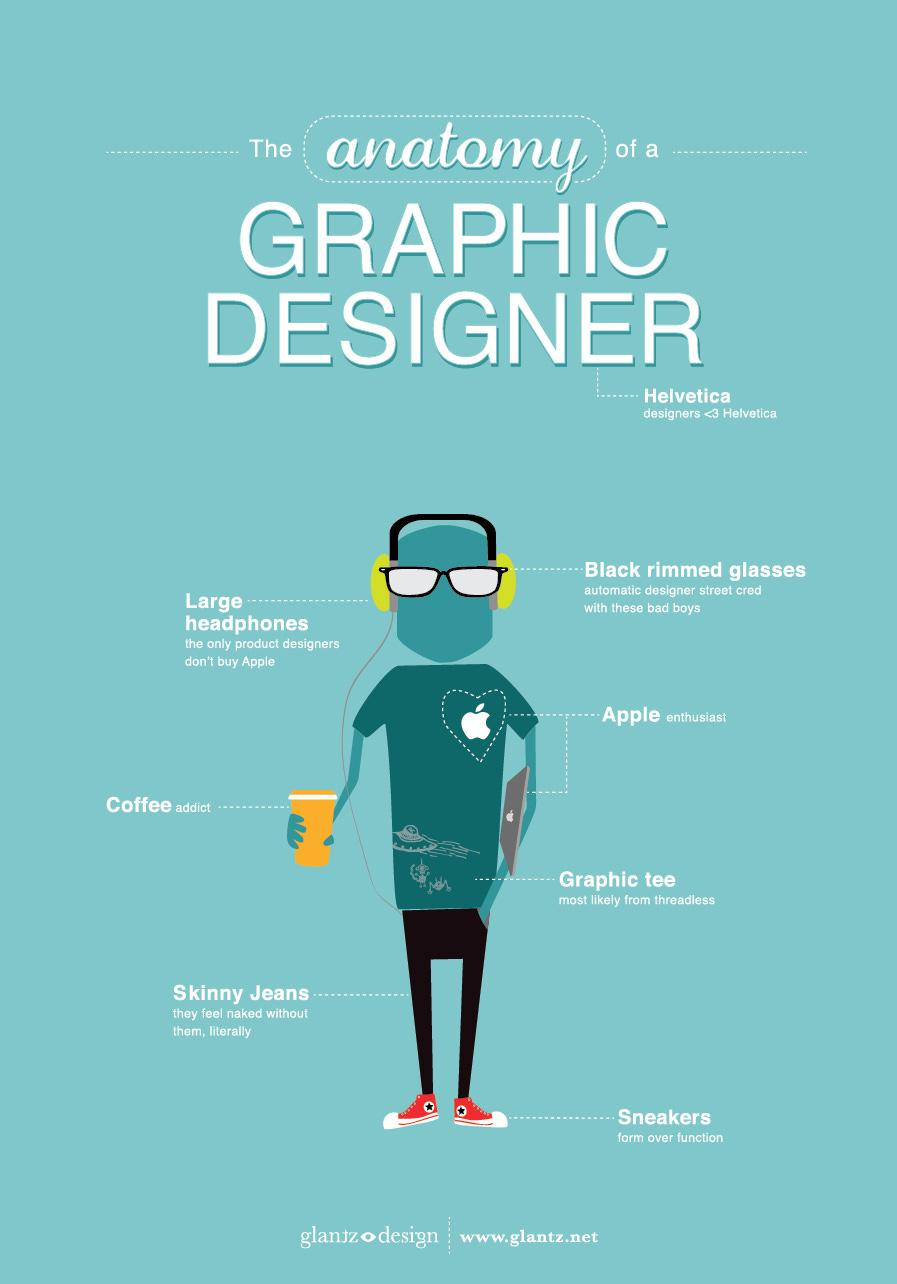Mention a couple of crucial points in this snapshot. The designer prefers to wear skinny jeans, which fit their body well. It is a common practice for graphic designers to wear graphic tees, specifically those that showcase their design skills and creativity. It is a commonly held belief that Helvetica designers prefer to wear sneakers. It is more likely that Helvetica designers will use black rimmed glasses due to their specific design and style. 